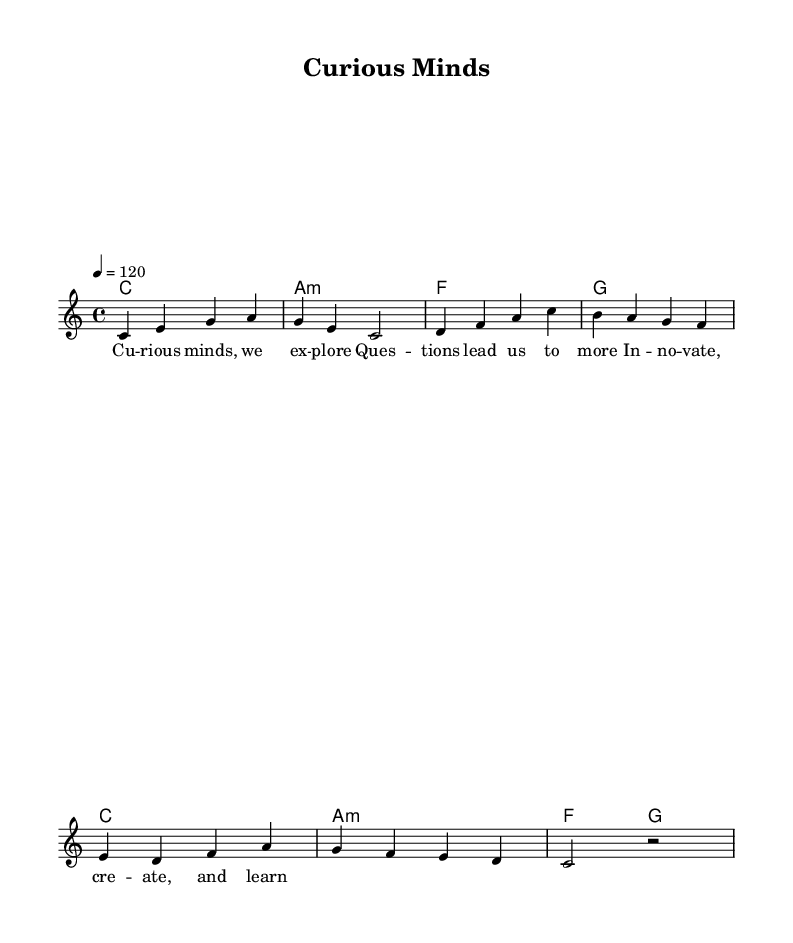What is the key signature of this music? The key signature is C major, which has no sharps or flats.
Answer: C major What is the time signature of the piece? The time signature is indicated as 4/4, meaning there are four beats in a measure and the quarter note gets one beat.
Answer: 4/4 What is the tempo marking of the piece? The tempo marking indicates a speed of 120 beats per minute, as noted in the tempo instructions.
Answer: 120 How many measures are there in the melody? By counting the groups of notes and separating them by the bar lines, there are a total of 8 measures in the melody part.
Answer: 8 What is the first chord in the harmony? The first chord is C major, indicated by the chord symbol 'c' at the beginning of the harmony section.
Answer: C What theme do the lyrics celebrate? The lyrics celebrate curiosity and innovation, as indicated by phrases like "Curious minds" and "Innovate, create, and learn."
Answer: Curiosity and innovation Which musical term describes the overall feel of this piece? This piece can be described as energetic, given the tempo and the uplifting lyrics focusing on curiosity and exploration.
Answer: Energetic 